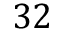<formula> <loc_0><loc_0><loc_500><loc_500>3 2</formula> 